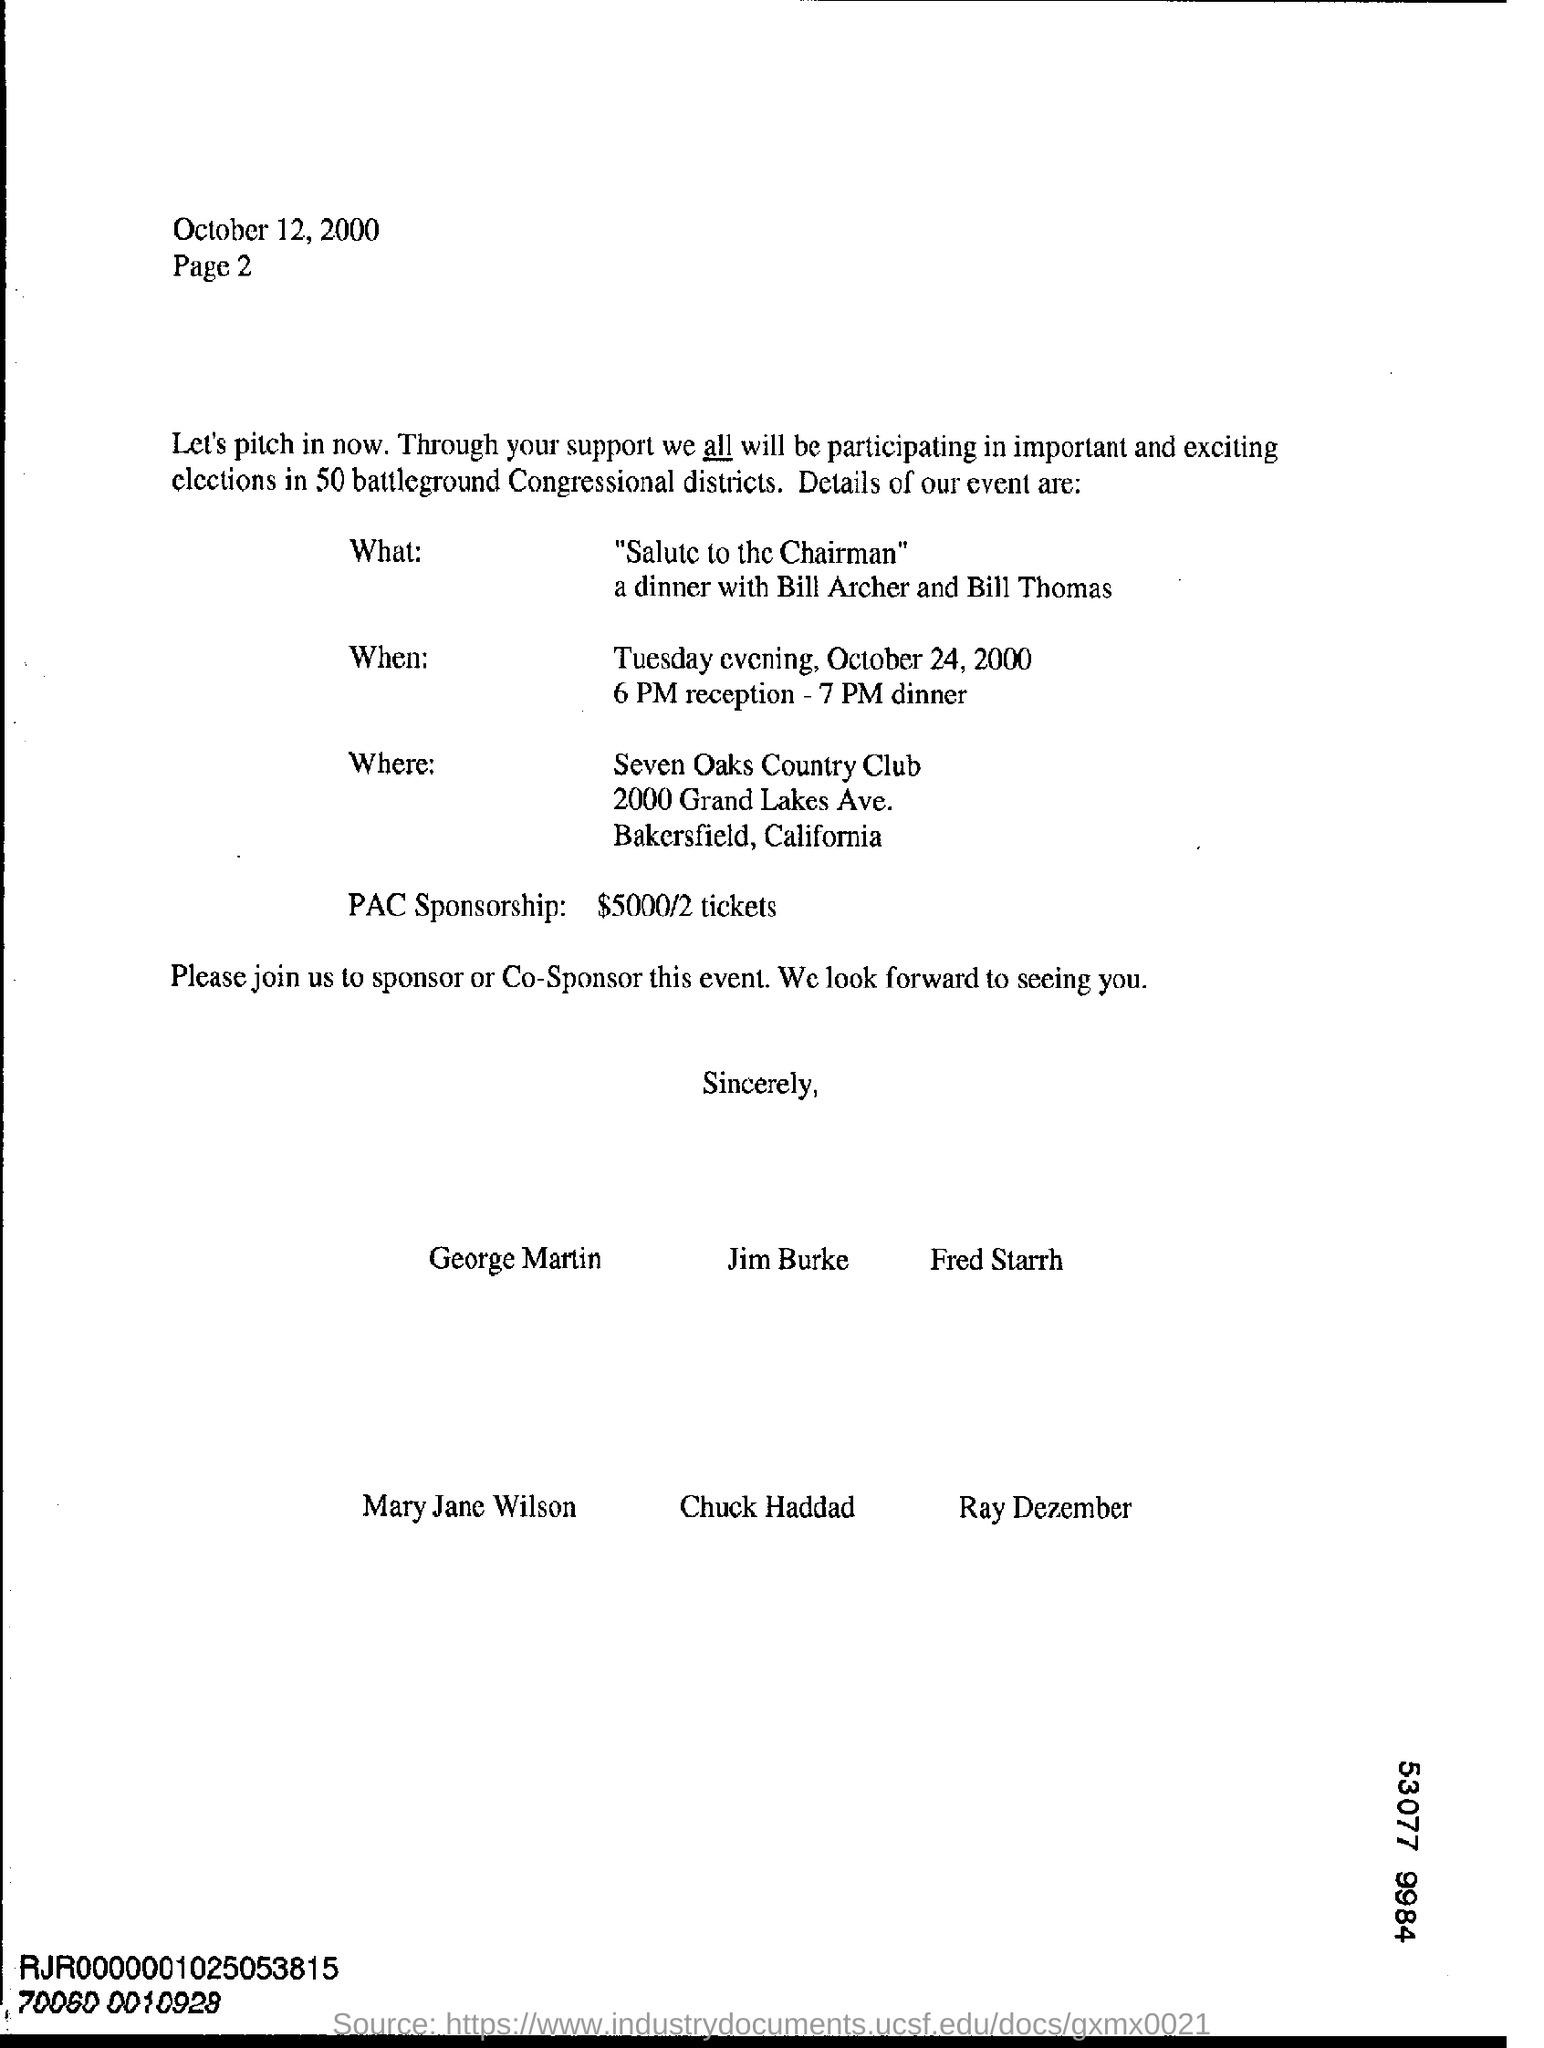Highlight a few significant elements in this photo. October 12, 2000 is the date on which this letter was sent. The event is being held at the Seven Oaks Country Club, which is a country club located in the country of [insert country]. The event is scheduled to take place on October 24, 2000. The event named 'Salute to the Chairman' is a dinner in which Bill Archer and Bill Thomas will attend. The PAC sponsorship mentioned in the letter is $5000 for two tickets. 